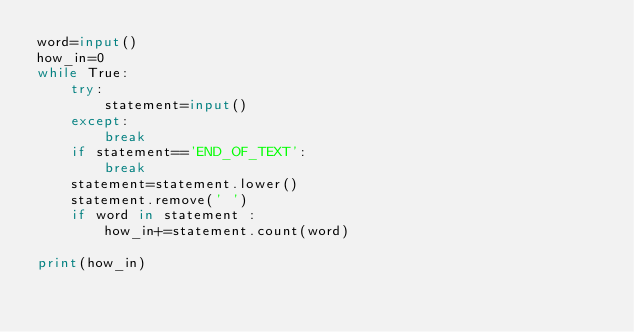<code> <loc_0><loc_0><loc_500><loc_500><_Python_>word=input()
how_in=0
while True:
    try:
        statement=input()
    except:
        break
    if statement=='END_OF_TEXT':
        break
    statement=statement.lower()
    statement.remove(' ')
    if word in statement :
        how_in+=statement.count(word)

print(how_in)</code> 